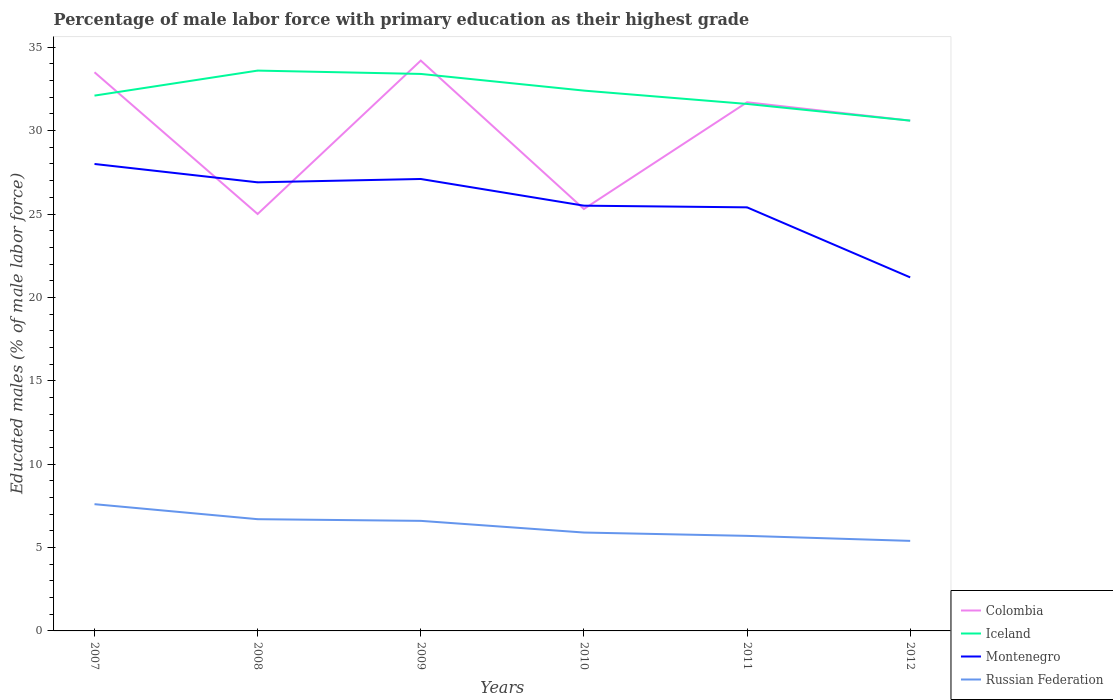Across all years, what is the maximum percentage of male labor force with primary education in Iceland?
Offer a terse response. 30.6. What is the total percentage of male labor force with primary education in Russian Federation in the graph?
Make the answer very short. 0.9. What is the difference between the highest and the second highest percentage of male labor force with primary education in Iceland?
Offer a very short reply. 3. How many years are there in the graph?
Keep it short and to the point. 6. Are the values on the major ticks of Y-axis written in scientific E-notation?
Your answer should be compact. No. Where does the legend appear in the graph?
Provide a succinct answer. Bottom right. How are the legend labels stacked?
Keep it short and to the point. Vertical. What is the title of the graph?
Provide a short and direct response. Percentage of male labor force with primary education as their highest grade. What is the label or title of the Y-axis?
Your answer should be compact. Educated males (% of male labor force). What is the Educated males (% of male labor force) of Colombia in 2007?
Your answer should be compact. 33.5. What is the Educated males (% of male labor force) in Iceland in 2007?
Your answer should be compact. 32.1. What is the Educated males (% of male labor force) in Montenegro in 2007?
Make the answer very short. 28. What is the Educated males (% of male labor force) of Russian Federation in 2007?
Offer a terse response. 7.6. What is the Educated males (% of male labor force) in Colombia in 2008?
Provide a succinct answer. 25. What is the Educated males (% of male labor force) in Iceland in 2008?
Ensure brevity in your answer.  33.6. What is the Educated males (% of male labor force) of Montenegro in 2008?
Give a very brief answer. 26.9. What is the Educated males (% of male labor force) in Russian Federation in 2008?
Keep it short and to the point. 6.7. What is the Educated males (% of male labor force) of Colombia in 2009?
Provide a short and direct response. 34.2. What is the Educated males (% of male labor force) of Iceland in 2009?
Offer a very short reply. 33.4. What is the Educated males (% of male labor force) in Montenegro in 2009?
Your response must be concise. 27.1. What is the Educated males (% of male labor force) of Russian Federation in 2009?
Offer a terse response. 6.6. What is the Educated males (% of male labor force) of Colombia in 2010?
Ensure brevity in your answer.  25.3. What is the Educated males (% of male labor force) of Iceland in 2010?
Ensure brevity in your answer.  32.4. What is the Educated males (% of male labor force) of Montenegro in 2010?
Offer a terse response. 25.5. What is the Educated males (% of male labor force) of Russian Federation in 2010?
Your response must be concise. 5.9. What is the Educated males (% of male labor force) in Colombia in 2011?
Provide a short and direct response. 31.7. What is the Educated males (% of male labor force) of Iceland in 2011?
Offer a terse response. 31.6. What is the Educated males (% of male labor force) of Montenegro in 2011?
Make the answer very short. 25.4. What is the Educated males (% of male labor force) of Russian Federation in 2011?
Give a very brief answer. 5.7. What is the Educated males (% of male labor force) in Colombia in 2012?
Ensure brevity in your answer.  30.6. What is the Educated males (% of male labor force) of Iceland in 2012?
Your answer should be very brief. 30.6. What is the Educated males (% of male labor force) in Montenegro in 2012?
Ensure brevity in your answer.  21.2. What is the Educated males (% of male labor force) of Russian Federation in 2012?
Your answer should be compact. 5.4. Across all years, what is the maximum Educated males (% of male labor force) in Colombia?
Keep it short and to the point. 34.2. Across all years, what is the maximum Educated males (% of male labor force) of Iceland?
Make the answer very short. 33.6. Across all years, what is the maximum Educated males (% of male labor force) in Russian Federation?
Your answer should be very brief. 7.6. Across all years, what is the minimum Educated males (% of male labor force) in Colombia?
Your response must be concise. 25. Across all years, what is the minimum Educated males (% of male labor force) of Iceland?
Your response must be concise. 30.6. Across all years, what is the minimum Educated males (% of male labor force) of Montenegro?
Offer a terse response. 21.2. Across all years, what is the minimum Educated males (% of male labor force) in Russian Federation?
Make the answer very short. 5.4. What is the total Educated males (% of male labor force) in Colombia in the graph?
Give a very brief answer. 180.3. What is the total Educated males (% of male labor force) of Iceland in the graph?
Give a very brief answer. 193.7. What is the total Educated males (% of male labor force) of Montenegro in the graph?
Offer a terse response. 154.1. What is the total Educated males (% of male labor force) of Russian Federation in the graph?
Ensure brevity in your answer.  37.9. What is the difference between the Educated males (% of male labor force) in Colombia in 2007 and that in 2008?
Ensure brevity in your answer.  8.5. What is the difference between the Educated males (% of male labor force) in Iceland in 2007 and that in 2008?
Provide a succinct answer. -1.5. What is the difference between the Educated males (% of male labor force) of Colombia in 2007 and that in 2009?
Ensure brevity in your answer.  -0.7. What is the difference between the Educated males (% of male labor force) of Iceland in 2007 and that in 2009?
Give a very brief answer. -1.3. What is the difference between the Educated males (% of male labor force) of Colombia in 2007 and that in 2010?
Make the answer very short. 8.2. What is the difference between the Educated males (% of male labor force) in Iceland in 2007 and that in 2010?
Your response must be concise. -0.3. What is the difference between the Educated males (% of male labor force) in Russian Federation in 2007 and that in 2010?
Offer a very short reply. 1.7. What is the difference between the Educated males (% of male labor force) of Colombia in 2007 and that in 2011?
Offer a terse response. 1.8. What is the difference between the Educated males (% of male labor force) of Iceland in 2007 and that in 2011?
Ensure brevity in your answer.  0.5. What is the difference between the Educated males (% of male labor force) of Russian Federation in 2007 and that in 2011?
Your response must be concise. 1.9. What is the difference between the Educated males (% of male labor force) in Iceland in 2007 and that in 2012?
Give a very brief answer. 1.5. What is the difference between the Educated males (% of male labor force) of Russian Federation in 2008 and that in 2009?
Make the answer very short. 0.1. What is the difference between the Educated males (% of male labor force) of Russian Federation in 2008 and that in 2010?
Make the answer very short. 0.8. What is the difference between the Educated males (% of male labor force) of Colombia in 2008 and that in 2011?
Keep it short and to the point. -6.7. What is the difference between the Educated males (% of male labor force) of Iceland in 2008 and that in 2012?
Your response must be concise. 3. What is the difference between the Educated males (% of male labor force) in Russian Federation in 2008 and that in 2012?
Give a very brief answer. 1.3. What is the difference between the Educated males (% of male labor force) in Colombia in 2009 and that in 2010?
Give a very brief answer. 8.9. What is the difference between the Educated males (% of male labor force) in Iceland in 2009 and that in 2010?
Make the answer very short. 1. What is the difference between the Educated males (% of male labor force) in Montenegro in 2009 and that in 2010?
Ensure brevity in your answer.  1.6. What is the difference between the Educated males (% of male labor force) in Montenegro in 2009 and that in 2011?
Give a very brief answer. 1.7. What is the difference between the Educated males (% of male labor force) of Montenegro in 2009 and that in 2012?
Ensure brevity in your answer.  5.9. What is the difference between the Educated males (% of male labor force) of Montenegro in 2010 and that in 2011?
Make the answer very short. 0.1. What is the difference between the Educated males (% of male labor force) of Russian Federation in 2010 and that in 2011?
Your answer should be compact. 0.2. What is the difference between the Educated males (% of male labor force) of Colombia in 2010 and that in 2012?
Ensure brevity in your answer.  -5.3. What is the difference between the Educated males (% of male labor force) in Iceland in 2010 and that in 2012?
Your answer should be very brief. 1.8. What is the difference between the Educated males (% of male labor force) in Montenegro in 2010 and that in 2012?
Your response must be concise. 4.3. What is the difference between the Educated males (% of male labor force) in Russian Federation in 2010 and that in 2012?
Your answer should be compact. 0.5. What is the difference between the Educated males (% of male labor force) of Colombia in 2011 and that in 2012?
Provide a succinct answer. 1.1. What is the difference between the Educated males (% of male labor force) of Iceland in 2011 and that in 2012?
Keep it short and to the point. 1. What is the difference between the Educated males (% of male labor force) in Montenegro in 2011 and that in 2012?
Offer a terse response. 4.2. What is the difference between the Educated males (% of male labor force) of Colombia in 2007 and the Educated males (% of male labor force) of Montenegro in 2008?
Make the answer very short. 6.6. What is the difference between the Educated males (% of male labor force) of Colombia in 2007 and the Educated males (% of male labor force) of Russian Federation in 2008?
Offer a very short reply. 26.8. What is the difference between the Educated males (% of male labor force) of Iceland in 2007 and the Educated males (% of male labor force) of Montenegro in 2008?
Offer a very short reply. 5.2. What is the difference between the Educated males (% of male labor force) of Iceland in 2007 and the Educated males (% of male labor force) of Russian Federation in 2008?
Offer a terse response. 25.4. What is the difference between the Educated males (% of male labor force) of Montenegro in 2007 and the Educated males (% of male labor force) of Russian Federation in 2008?
Make the answer very short. 21.3. What is the difference between the Educated males (% of male labor force) in Colombia in 2007 and the Educated males (% of male labor force) in Iceland in 2009?
Your answer should be compact. 0.1. What is the difference between the Educated males (% of male labor force) in Colombia in 2007 and the Educated males (% of male labor force) in Montenegro in 2009?
Give a very brief answer. 6.4. What is the difference between the Educated males (% of male labor force) of Colombia in 2007 and the Educated males (% of male labor force) of Russian Federation in 2009?
Your answer should be compact. 26.9. What is the difference between the Educated males (% of male labor force) in Iceland in 2007 and the Educated males (% of male labor force) in Montenegro in 2009?
Your answer should be compact. 5. What is the difference between the Educated males (% of male labor force) in Iceland in 2007 and the Educated males (% of male labor force) in Russian Federation in 2009?
Your answer should be very brief. 25.5. What is the difference between the Educated males (% of male labor force) of Montenegro in 2007 and the Educated males (% of male labor force) of Russian Federation in 2009?
Provide a succinct answer. 21.4. What is the difference between the Educated males (% of male labor force) of Colombia in 2007 and the Educated males (% of male labor force) of Iceland in 2010?
Offer a terse response. 1.1. What is the difference between the Educated males (% of male labor force) of Colombia in 2007 and the Educated males (% of male labor force) of Russian Federation in 2010?
Make the answer very short. 27.6. What is the difference between the Educated males (% of male labor force) of Iceland in 2007 and the Educated males (% of male labor force) of Montenegro in 2010?
Your response must be concise. 6.6. What is the difference between the Educated males (% of male labor force) in Iceland in 2007 and the Educated males (% of male labor force) in Russian Federation in 2010?
Your answer should be very brief. 26.2. What is the difference between the Educated males (% of male labor force) in Montenegro in 2007 and the Educated males (% of male labor force) in Russian Federation in 2010?
Ensure brevity in your answer.  22.1. What is the difference between the Educated males (% of male labor force) of Colombia in 2007 and the Educated males (% of male labor force) of Montenegro in 2011?
Keep it short and to the point. 8.1. What is the difference between the Educated males (% of male labor force) in Colombia in 2007 and the Educated males (% of male labor force) in Russian Federation in 2011?
Your response must be concise. 27.8. What is the difference between the Educated males (% of male labor force) of Iceland in 2007 and the Educated males (% of male labor force) of Russian Federation in 2011?
Give a very brief answer. 26.4. What is the difference between the Educated males (% of male labor force) in Montenegro in 2007 and the Educated males (% of male labor force) in Russian Federation in 2011?
Make the answer very short. 22.3. What is the difference between the Educated males (% of male labor force) of Colombia in 2007 and the Educated males (% of male labor force) of Russian Federation in 2012?
Your answer should be very brief. 28.1. What is the difference between the Educated males (% of male labor force) in Iceland in 2007 and the Educated males (% of male labor force) in Russian Federation in 2012?
Offer a very short reply. 26.7. What is the difference between the Educated males (% of male labor force) of Montenegro in 2007 and the Educated males (% of male labor force) of Russian Federation in 2012?
Give a very brief answer. 22.6. What is the difference between the Educated males (% of male labor force) in Colombia in 2008 and the Educated males (% of male labor force) in Montenegro in 2009?
Provide a short and direct response. -2.1. What is the difference between the Educated males (% of male labor force) in Colombia in 2008 and the Educated males (% of male labor force) in Russian Federation in 2009?
Your answer should be very brief. 18.4. What is the difference between the Educated males (% of male labor force) of Iceland in 2008 and the Educated males (% of male labor force) of Montenegro in 2009?
Offer a terse response. 6.5. What is the difference between the Educated males (% of male labor force) of Iceland in 2008 and the Educated males (% of male labor force) of Russian Federation in 2009?
Make the answer very short. 27. What is the difference between the Educated males (% of male labor force) in Montenegro in 2008 and the Educated males (% of male labor force) in Russian Federation in 2009?
Offer a very short reply. 20.3. What is the difference between the Educated males (% of male labor force) in Colombia in 2008 and the Educated males (% of male labor force) in Iceland in 2010?
Ensure brevity in your answer.  -7.4. What is the difference between the Educated males (% of male labor force) in Colombia in 2008 and the Educated males (% of male labor force) in Russian Federation in 2010?
Provide a short and direct response. 19.1. What is the difference between the Educated males (% of male labor force) in Iceland in 2008 and the Educated males (% of male labor force) in Russian Federation in 2010?
Your answer should be compact. 27.7. What is the difference between the Educated males (% of male labor force) of Colombia in 2008 and the Educated males (% of male labor force) of Russian Federation in 2011?
Offer a terse response. 19.3. What is the difference between the Educated males (% of male labor force) of Iceland in 2008 and the Educated males (% of male labor force) of Montenegro in 2011?
Your answer should be compact. 8.2. What is the difference between the Educated males (% of male labor force) in Iceland in 2008 and the Educated males (% of male labor force) in Russian Federation in 2011?
Keep it short and to the point. 27.9. What is the difference between the Educated males (% of male labor force) in Montenegro in 2008 and the Educated males (% of male labor force) in Russian Federation in 2011?
Make the answer very short. 21.2. What is the difference between the Educated males (% of male labor force) of Colombia in 2008 and the Educated males (% of male labor force) of Montenegro in 2012?
Make the answer very short. 3.8. What is the difference between the Educated males (% of male labor force) of Colombia in 2008 and the Educated males (% of male labor force) of Russian Federation in 2012?
Keep it short and to the point. 19.6. What is the difference between the Educated males (% of male labor force) of Iceland in 2008 and the Educated males (% of male labor force) of Montenegro in 2012?
Offer a terse response. 12.4. What is the difference between the Educated males (% of male labor force) of Iceland in 2008 and the Educated males (% of male labor force) of Russian Federation in 2012?
Your answer should be compact. 28.2. What is the difference between the Educated males (% of male labor force) of Colombia in 2009 and the Educated males (% of male labor force) of Iceland in 2010?
Keep it short and to the point. 1.8. What is the difference between the Educated males (% of male labor force) of Colombia in 2009 and the Educated males (% of male labor force) of Montenegro in 2010?
Ensure brevity in your answer.  8.7. What is the difference between the Educated males (% of male labor force) of Colombia in 2009 and the Educated males (% of male labor force) of Russian Federation in 2010?
Give a very brief answer. 28.3. What is the difference between the Educated males (% of male labor force) of Iceland in 2009 and the Educated males (% of male labor force) of Montenegro in 2010?
Ensure brevity in your answer.  7.9. What is the difference between the Educated males (% of male labor force) of Montenegro in 2009 and the Educated males (% of male labor force) of Russian Federation in 2010?
Offer a very short reply. 21.2. What is the difference between the Educated males (% of male labor force) of Colombia in 2009 and the Educated males (% of male labor force) of Montenegro in 2011?
Ensure brevity in your answer.  8.8. What is the difference between the Educated males (% of male labor force) in Colombia in 2009 and the Educated males (% of male labor force) in Russian Federation in 2011?
Give a very brief answer. 28.5. What is the difference between the Educated males (% of male labor force) of Iceland in 2009 and the Educated males (% of male labor force) of Russian Federation in 2011?
Offer a very short reply. 27.7. What is the difference between the Educated males (% of male labor force) of Montenegro in 2009 and the Educated males (% of male labor force) of Russian Federation in 2011?
Your response must be concise. 21.4. What is the difference between the Educated males (% of male labor force) in Colombia in 2009 and the Educated males (% of male labor force) in Iceland in 2012?
Your response must be concise. 3.6. What is the difference between the Educated males (% of male labor force) in Colombia in 2009 and the Educated males (% of male labor force) in Russian Federation in 2012?
Keep it short and to the point. 28.8. What is the difference between the Educated males (% of male labor force) in Iceland in 2009 and the Educated males (% of male labor force) in Montenegro in 2012?
Make the answer very short. 12.2. What is the difference between the Educated males (% of male labor force) of Iceland in 2009 and the Educated males (% of male labor force) of Russian Federation in 2012?
Make the answer very short. 28. What is the difference between the Educated males (% of male labor force) in Montenegro in 2009 and the Educated males (% of male labor force) in Russian Federation in 2012?
Your response must be concise. 21.7. What is the difference between the Educated males (% of male labor force) of Colombia in 2010 and the Educated males (% of male labor force) of Iceland in 2011?
Make the answer very short. -6.3. What is the difference between the Educated males (% of male labor force) in Colombia in 2010 and the Educated males (% of male labor force) in Russian Federation in 2011?
Provide a succinct answer. 19.6. What is the difference between the Educated males (% of male labor force) in Iceland in 2010 and the Educated males (% of male labor force) in Russian Federation in 2011?
Make the answer very short. 26.7. What is the difference between the Educated males (% of male labor force) in Montenegro in 2010 and the Educated males (% of male labor force) in Russian Federation in 2011?
Your answer should be very brief. 19.8. What is the difference between the Educated males (% of male labor force) in Colombia in 2010 and the Educated males (% of male labor force) in Iceland in 2012?
Your answer should be compact. -5.3. What is the difference between the Educated males (% of male labor force) in Colombia in 2010 and the Educated males (% of male labor force) in Russian Federation in 2012?
Give a very brief answer. 19.9. What is the difference between the Educated males (% of male labor force) in Montenegro in 2010 and the Educated males (% of male labor force) in Russian Federation in 2012?
Your answer should be very brief. 20.1. What is the difference between the Educated males (% of male labor force) of Colombia in 2011 and the Educated males (% of male labor force) of Montenegro in 2012?
Offer a very short reply. 10.5. What is the difference between the Educated males (% of male labor force) in Colombia in 2011 and the Educated males (% of male labor force) in Russian Federation in 2012?
Your answer should be very brief. 26.3. What is the difference between the Educated males (% of male labor force) of Iceland in 2011 and the Educated males (% of male labor force) of Montenegro in 2012?
Keep it short and to the point. 10.4. What is the difference between the Educated males (% of male labor force) in Iceland in 2011 and the Educated males (% of male labor force) in Russian Federation in 2012?
Provide a short and direct response. 26.2. What is the difference between the Educated males (% of male labor force) in Montenegro in 2011 and the Educated males (% of male labor force) in Russian Federation in 2012?
Make the answer very short. 20. What is the average Educated males (% of male labor force) in Colombia per year?
Provide a short and direct response. 30.05. What is the average Educated males (% of male labor force) of Iceland per year?
Offer a terse response. 32.28. What is the average Educated males (% of male labor force) in Montenegro per year?
Offer a very short reply. 25.68. What is the average Educated males (% of male labor force) of Russian Federation per year?
Your response must be concise. 6.32. In the year 2007, what is the difference between the Educated males (% of male labor force) of Colombia and Educated males (% of male labor force) of Iceland?
Give a very brief answer. 1.4. In the year 2007, what is the difference between the Educated males (% of male labor force) in Colombia and Educated males (% of male labor force) in Russian Federation?
Offer a terse response. 25.9. In the year 2007, what is the difference between the Educated males (% of male labor force) of Iceland and Educated males (% of male labor force) of Montenegro?
Your answer should be compact. 4.1. In the year 2007, what is the difference between the Educated males (% of male labor force) of Montenegro and Educated males (% of male labor force) of Russian Federation?
Provide a succinct answer. 20.4. In the year 2008, what is the difference between the Educated males (% of male labor force) of Iceland and Educated males (% of male labor force) of Montenegro?
Your answer should be very brief. 6.7. In the year 2008, what is the difference between the Educated males (% of male labor force) of Iceland and Educated males (% of male labor force) of Russian Federation?
Your answer should be compact. 26.9. In the year 2008, what is the difference between the Educated males (% of male labor force) of Montenegro and Educated males (% of male labor force) of Russian Federation?
Ensure brevity in your answer.  20.2. In the year 2009, what is the difference between the Educated males (% of male labor force) in Colombia and Educated males (% of male labor force) in Iceland?
Give a very brief answer. 0.8. In the year 2009, what is the difference between the Educated males (% of male labor force) in Colombia and Educated males (% of male labor force) in Russian Federation?
Your response must be concise. 27.6. In the year 2009, what is the difference between the Educated males (% of male labor force) of Iceland and Educated males (% of male labor force) of Montenegro?
Keep it short and to the point. 6.3. In the year 2009, what is the difference between the Educated males (% of male labor force) of Iceland and Educated males (% of male labor force) of Russian Federation?
Provide a succinct answer. 26.8. In the year 2010, what is the difference between the Educated males (% of male labor force) in Colombia and Educated males (% of male labor force) in Iceland?
Keep it short and to the point. -7.1. In the year 2010, what is the difference between the Educated males (% of male labor force) of Colombia and Educated males (% of male labor force) of Russian Federation?
Your response must be concise. 19.4. In the year 2010, what is the difference between the Educated males (% of male labor force) of Iceland and Educated males (% of male labor force) of Russian Federation?
Your answer should be very brief. 26.5. In the year 2010, what is the difference between the Educated males (% of male labor force) of Montenegro and Educated males (% of male labor force) of Russian Federation?
Offer a terse response. 19.6. In the year 2011, what is the difference between the Educated males (% of male labor force) of Colombia and Educated males (% of male labor force) of Montenegro?
Give a very brief answer. 6.3. In the year 2011, what is the difference between the Educated males (% of male labor force) of Iceland and Educated males (% of male labor force) of Montenegro?
Make the answer very short. 6.2. In the year 2011, what is the difference between the Educated males (% of male labor force) in Iceland and Educated males (% of male labor force) in Russian Federation?
Offer a terse response. 25.9. In the year 2012, what is the difference between the Educated males (% of male labor force) of Colombia and Educated males (% of male labor force) of Iceland?
Provide a succinct answer. 0. In the year 2012, what is the difference between the Educated males (% of male labor force) in Colombia and Educated males (% of male labor force) in Montenegro?
Ensure brevity in your answer.  9.4. In the year 2012, what is the difference between the Educated males (% of male labor force) of Colombia and Educated males (% of male labor force) of Russian Federation?
Ensure brevity in your answer.  25.2. In the year 2012, what is the difference between the Educated males (% of male labor force) of Iceland and Educated males (% of male labor force) of Russian Federation?
Your response must be concise. 25.2. What is the ratio of the Educated males (% of male labor force) of Colombia in 2007 to that in 2008?
Provide a succinct answer. 1.34. What is the ratio of the Educated males (% of male labor force) in Iceland in 2007 to that in 2008?
Your answer should be very brief. 0.96. What is the ratio of the Educated males (% of male labor force) in Montenegro in 2007 to that in 2008?
Your answer should be compact. 1.04. What is the ratio of the Educated males (% of male labor force) of Russian Federation in 2007 to that in 2008?
Your response must be concise. 1.13. What is the ratio of the Educated males (% of male labor force) in Colombia in 2007 to that in 2009?
Offer a terse response. 0.98. What is the ratio of the Educated males (% of male labor force) of Iceland in 2007 to that in 2009?
Give a very brief answer. 0.96. What is the ratio of the Educated males (% of male labor force) in Montenegro in 2007 to that in 2009?
Ensure brevity in your answer.  1.03. What is the ratio of the Educated males (% of male labor force) in Russian Federation in 2007 to that in 2009?
Provide a succinct answer. 1.15. What is the ratio of the Educated males (% of male labor force) in Colombia in 2007 to that in 2010?
Give a very brief answer. 1.32. What is the ratio of the Educated males (% of male labor force) of Iceland in 2007 to that in 2010?
Keep it short and to the point. 0.99. What is the ratio of the Educated males (% of male labor force) of Montenegro in 2007 to that in 2010?
Make the answer very short. 1.1. What is the ratio of the Educated males (% of male labor force) of Russian Federation in 2007 to that in 2010?
Your response must be concise. 1.29. What is the ratio of the Educated males (% of male labor force) in Colombia in 2007 to that in 2011?
Offer a very short reply. 1.06. What is the ratio of the Educated males (% of male labor force) of Iceland in 2007 to that in 2011?
Offer a terse response. 1.02. What is the ratio of the Educated males (% of male labor force) of Montenegro in 2007 to that in 2011?
Your answer should be very brief. 1.1. What is the ratio of the Educated males (% of male labor force) of Russian Federation in 2007 to that in 2011?
Provide a succinct answer. 1.33. What is the ratio of the Educated males (% of male labor force) of Colombia in 2007 to that in 2012?
Offer a very short reply. 1.09. What is the ratio of the Educated males (% of male labor force) of Iceland in 2007 to that in 2012?
Offer a terse response. 1.05. What is the ratio of the Educated males (% of male labor force) in Montenegro in 2007 to that in 2012?
Give a very brief answer. 1.32. What is the ratio of the Educated males (% of male labor force) of Russian Federation in 2007 to that in 2012?
Your answer should be very brief. 1.41. What is the ratio of the Educated males (% of male labor force) of Colombia in 2008 to that in 2009?
Offer a very short reply. 0.73. What is the ratio of the Educated males (% of male labor force) in Montenegro in 2008 to that in 2009?
Give a very brief answer. 0.99. What is the ratio of the Educated males (% of male labor force) of Russian Federation in 2008 to that in 2009?
Ensure brevity in your answer.  1.02. What is the ratio of the Educated males (% of male labor force) in Colombia in 2008 to that in 2010?
Keep it short and to the point. 0.99. What is the ratio of the Educated males (% of male labor force) of Montenegro in 2008 to that in 2010?
Keep it short and to the point. 1.05. What is the ratio of the Educated males (% of male labor force) in Russian Federation in 2008 to that in 2010?
Keep it short and to the point. 1.14. What is the ratio of the Educated males (% of male labor force) in Colombia in 2008 to that in 2011?
Offer a very short reply. 0.79. What is the ratio of the Educated males (% of male labor force) of Iceland in 2008 to that in 2011?
Ensure brevity in your answer.  1.06. What is the ratio of the Educated males (% of male labor force) in Montenegro in 2008 to that in 2011?
Keep it short and to the point. 1.06. What is the ratio of the Educated males (% of male labor force) in Russian Federation in 2008 to that in 2011?
Ensure brevity in your answer.  1.18. What is the ratio of the Educated males (% of male labor force) of Colombia in 2008 to that in 2012?
Your response must be concise. 0.82. What is the ratio of the Educated males (% of male labor force) in Iceland in 2008 to that in 2012?
Make the answer very short. 1.1. What is the ratio of the Educated males (% of male labor force) of Montenegro in 2008 to that in 2012?
Provide a succinct answer. 1.27. What is the ratio of the Educated males (% of male labor force) of Russian Federation in 2008 to that in 2012?
Provide a succinct answer. 1.24. What is the ratio of the Educated males (% of male labor force) in Colombia in 2009 to that in 2010?
Give a very brief answer. 1.35. What is the ratio of the Educated males (% of male labor force) of Iceland in 2009 to that in 2010?
Your answer should be compact. 1.03. What is the ratio of the Educated males (% of male labor force) in Montenegro in 2009 to that in 2010?
Offer a very short reply. 1.06. What is the ratio of the Educated males (% of male labor force) of Russian Federation in 2009 to that in 2010?
Ensure brevity in your answer.  1.12. What is the ratio of the Educated males (% of male labor force) of Colombia in 2009 to that in 2011?
Offer a very short reply. 1.08. What is the ratio of the Educated males (% of male labor force) in Iceland in 2009 to that in 2011?
Offer a terse response. 1.06. What is the ratio of the Educated males (% of male labor force) in Montenegro in 2009 to that in 2011?
Keep it short and to the point. 1.07. What is the ratio of the Educated males (% of male labor force) of Russian Federation in 2009 to that in 2011?
Offer a terse response. 1.16. What is the ratio of the Educated males (% of male labor force) in Colombia in 2009 to that in 2012?
Keep it short and to the point. 1.12. What is the ratio of the Educated males (% of male labor force) of Iceland in 2009 to that in 2012?
Provide a short and direct response. 1.09. What is the ratio of the Educated males (% of male labor force) of Montenegro in 2009 to that in 2012?
Provide a short and direct response. 1.28. What is the ratio of the Educated males (% of male labor force) of Russian Federation in 2009 to that in 2012?
Provide a short and direct response. 1.22. What is the ratio of the Educated males (% of male labor force) of Colombia in 2010 to that in 2011?
Keep it short and to the point. 0.8. What is the ratio of the Educated males (% of male labor force) of Iceland in 2010 to that in 2011?
Your response must be concise. 1.03. What is the ratio of the Educated males (% of male labor force) in Russian Federation in 2010 to that in 2011?
Your response must be concise. 1.04. What is the ratio of the Educated males (% of male labor force) of Colombia in 2010 to that in 2012?
Your answer should be very brief. 0.83. What is the ratio of the Educated males (% of male labor force) of Iceland in 2010 to that in 2012?
Give a very brief answer. 1.06. What is the ratio of the Educated males (% of male labor force) of Montenegro in 2010 to that in 2012?
Provide a succinct answer. 1.2. What is the ratio of the Educated males (% of male labor force) in Russian Federation in 2010 to that in 2012?
Ensure brevity in your answer.  1.09. What is the ratio of the Educated males (% of male labor force) in Colombia in 2011 to that in 2012?
Provide a succinct answer. 1.04. What is the ratio of the Educated males (% of male labor force) of Iceland in 2011 to that in 2012?
Give a very brief answer. 1.03. What is the ratio of the Educated males (% of male labor force) of Montenegro in 2011 to that in 2012?
Your answer should be compact. 1.2. What is the ratio of the Educated males (% of male labor force) in Russian Federation in 2011 to that in 2012?
Ensure brevity in your answer.  1.06. What is the difference between the highest and the second highest Educated males (% of male labor force) in Colombia?
Your answer should be compact. 0.7. What is the difference between the highest and the second highest Educated males (% of male labor force) in Iceland?
Ensure brevity in your answer.  0.2. What is the difference between the highest and the second highest Educated males (% of male labor force) in Montenegro?
Provide a succinct answer. 0.9. What is the difference between the highest and the lowest Educated males (% of male labor force) in Colombia?
Give a very brief answer. 9.2. What is the difference between the highest and the lowest Educated males (% of male labor force) in Montenegro?
Give a very brief answer. 6.8. What is the difference between the highest and the lowest Educated males (% of male labor force) of Russian Federation?
Your answer should be very brief. 2.2. 